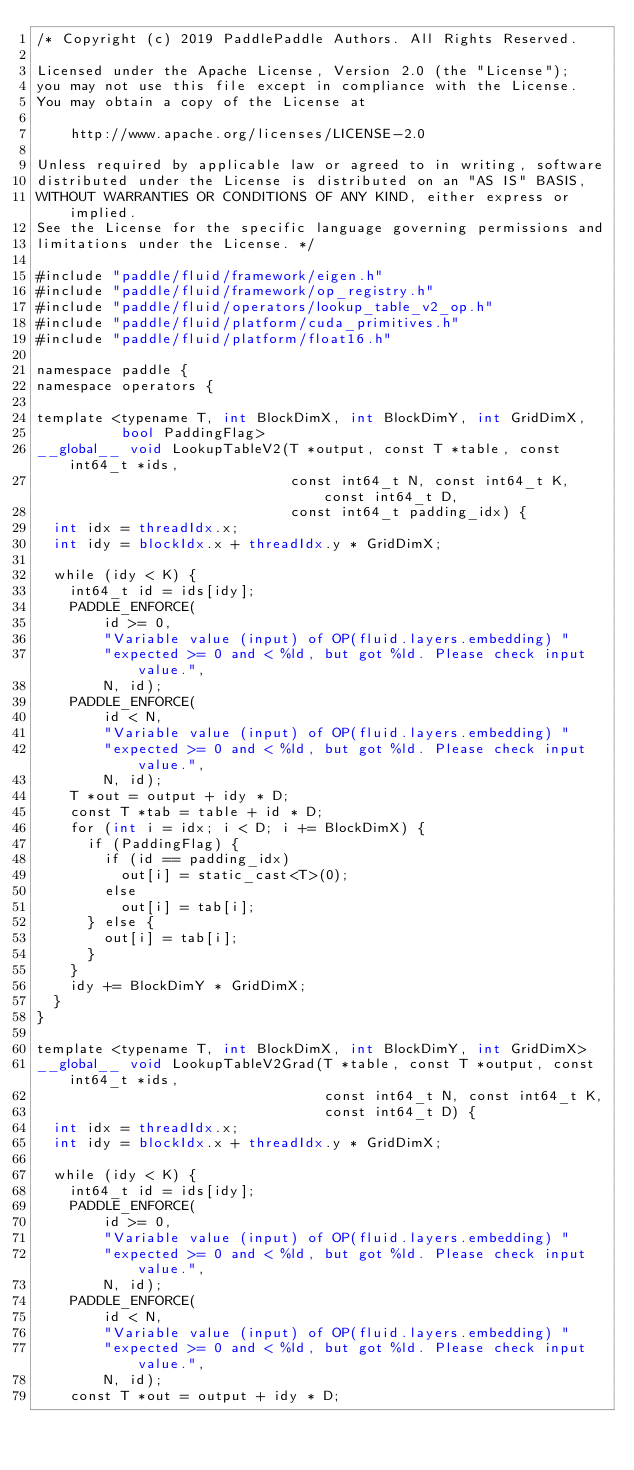Convert code to text. <code><loc_0><loc_0><loc_500><loc_500><_Cuda_>/* Copyright (c) 2019 PaddlePaddle Authors. All Rights Reserved.

Licensed under the Apache License, Version 2.0 (the "License");
you may not use this file except in compliance with the License.
You may obtain a copy of the License at

    http://www.apache.org/licenses/LICENSE-2.0

Unless required by applicable law or agreed to in writing, software
distributed under the License is distributed on an "AS IS" BASIS,
WITHOUT WARRANTIES OR CONDITIONS OF ANY KIND, either express or implied.
See the License for the specific language governing permissions and
limitations under the License. */

#include "paddle/fluid/framework/eigen.h"
#include "paddle/fluid/framework/op_registry.h"
#include "paddle/fluid/operators/lookup_table_v2_op.h"
#include "paddle/fluid/platform/cuda_primitives.h"
#include "paddle/fluid/platform/float16.h"

namespace paddle {
namespace operators {

template <typename T, int BlockDimX, int BlockDimY, int GridDimX,
          bool PaddingFlag>
__global__ void LookupTableV2(T *output, const T *table, const int64_t *ids,
                              const int64_t N, const int64_t K, const int64_t D,
                              const int64_t padding_idx) {
  int idx = threadIdx.x;
  int idy = blockIdx.x + threadIdx.y * GridDimX;

  while (idy < K) {
    int64_t id = ids[idy];
    PADDLE_ENFORCE(
        id >= 0,
        "Variable value (input) of OP(fluid.layers.embedding) "
        "expected >= 0 and < %ld, but got %ld. Please check input value.",
        N, id);
    PADDLE_ENFORCE(
        id < N,
        "Variable value (input) of OP(fluid.layers.embedding) "
        "expected >= 0 and < %ld, but got %ld. Please check input value.",
        N, id);
    T *out = output + idy * D;
    const T *tab = table + id * D;
    for (int i = idx; i < D; i += BlockDimX) {
      if (PaddingFlag) {
        if (id == padding_idx)
          out[i] = static_cast<T>(0);
        else
          out[i] = tab[i];
      } else {
        out[i] = tab[i];
      }
    }
    idy += BlockDimY * GridDimX;
  }
}

template <typename T, int BlockDimX, int BlockDimY, int GridDimX>
__global__ void LookupTableV2Grad(T *table, const T *output, const int64_t *ids,
                                  const int64_t N, const int64_t K,
                                  const int64_t D) {
  int idx = threadIdx.x;
  int idy = blockIdx.x + threadIdx.y * GridDimX;

  while (idy < K) {
    int64_t id = ids[idy];
    PADDLE_ENFORCE(
        id >= 0,
        "Variable value (input) of OP(fluid.layers.embedding) "
        "expected >= 0 and < %ld, but got %ld. Please check input value.",
        N, id);
    PADDLE_ENFORCE(
        id < N,
        "Variable value (input) of OP(fluid.layers.embedding) "
        "expected >= 0 and < %ld, but got %ld. Please check input value.",
        N, id);
    const T *out = output + idy * D;</code> 